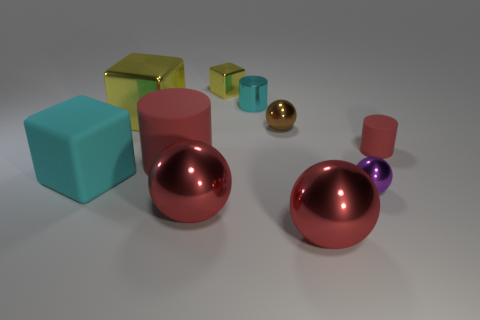How many large matte objects are the same color as the tiny metal cylinder?
Make the answer very short. 1. Does the brown metallic object have the same shape as the big object behind the large rubber cylinder?
Make the answer very short. No. There is another matte cylinder that is the same color as the big cylinder; what size is it?
Make the answer very short. Small. There is a rubber object that is to the right of the brown sphere; is it the same shape as the big red rubber thing?
Your response must be concise. Yes. There is a large metal object that is right of the shiny cube that is right of the cylinder on the left side of the tiny yellow metallic cube; what is its shape?
Offer a very short reply. Sphere. There is a big red object behind the big matte cube; what material is it?
Your answer should be very brief. Rubber. What color is the metallic block that is the same size as the brown thing?
Offer a very short reply. Yellow. How many other objects are the same shape as the big yellow shiny object?
Your answer should be very brief. 2. Do the brown ball and the cyan cylinder have the same size?
Offer a terse response. Yes. Are there more purple metallic things left of the big yellow metallic block than purple spheres that are in front of the small red cylinder?
Offer a very short reply. No. 